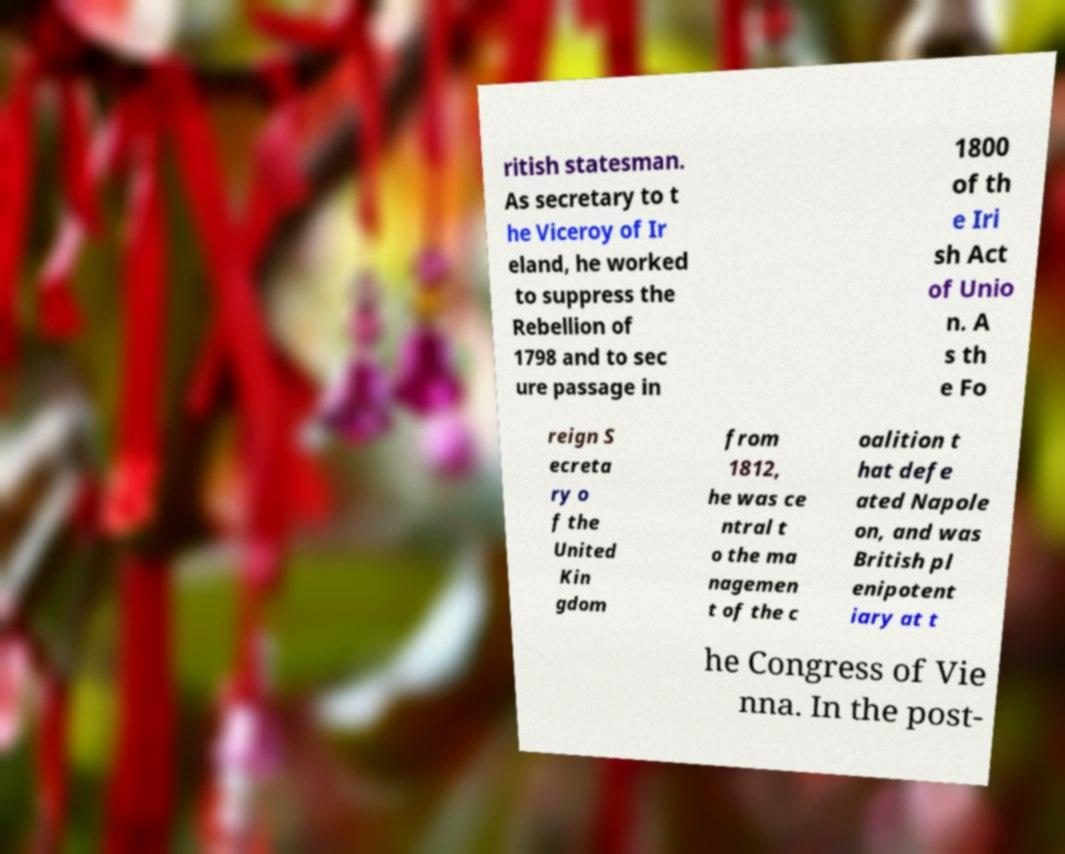For documentation purposes, I need the text within this image transcribed. Could you provide that? ritish statesman. As secretary to t he Viceroy of Ir eland, he worked to suppress the Rebellion of 1798 and to sec ure passage in 1800 of th e Iri sh Act of Unio n. A s th e Fo reign S ecreta ry o f the United Kin gdom from 1812, he was ce ntral t o the ma nagemen t of the c oalition t hat defe ated Napole on, and was British pl enipotent iary at t he Congress of Vie nna. In the post- 